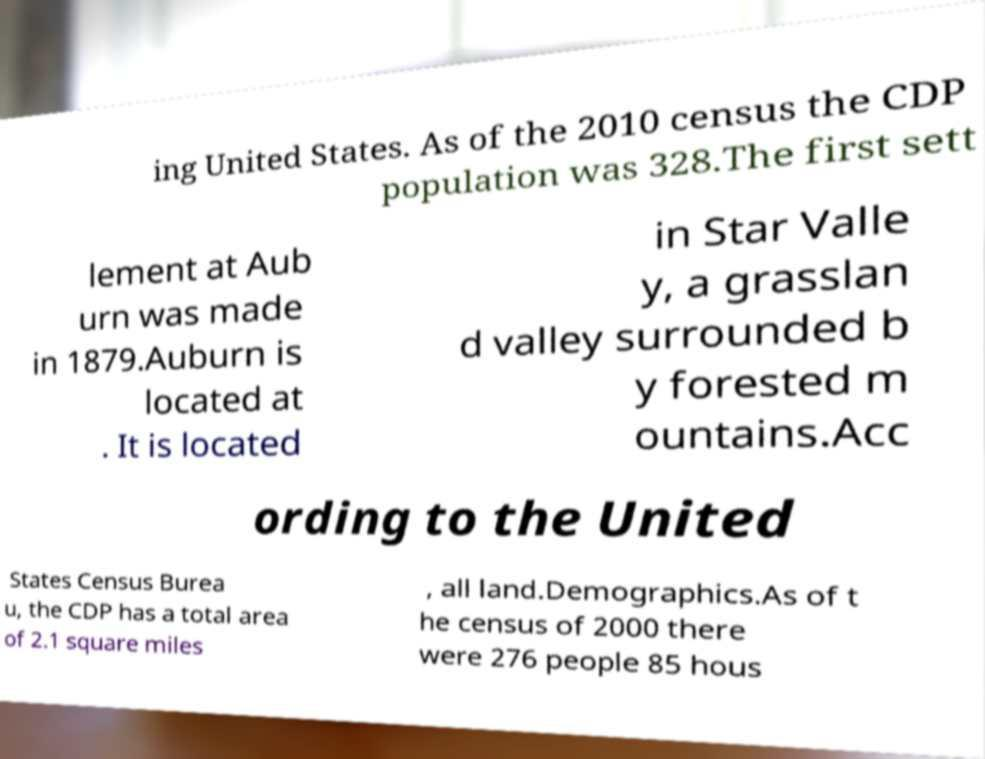What messages or text are displayed in this image? I need them in a readable, typed format. ing United States. As of the 2010 census the CDP population was 328.The first sett lement at Aub urn was made in 1879.Auburn is located at . It is located in Star Valle y, a grasslan d valley surrounded b y forested m ountains.Acc ording to the United States Census Burea u, the CDP has a total area of 2.1 square miles , all land.Demographics.As of t he census of 2000 there were 276 people 85 hous 